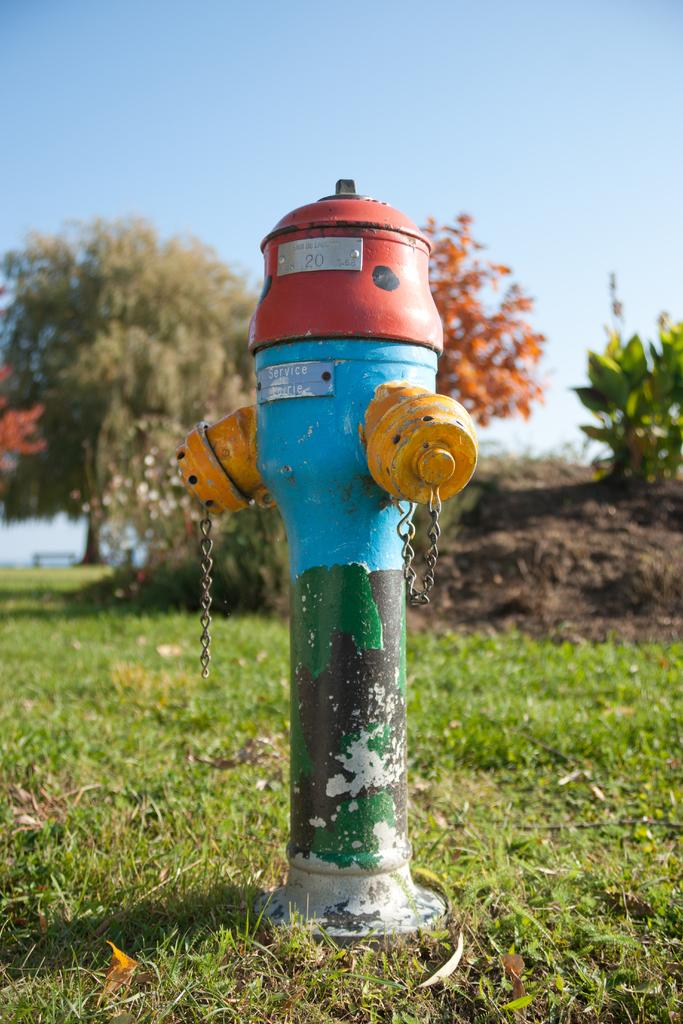<image>
Share a concise interpretation of the image provided. A strange and colorful fire hydrant with a number 20 on the silver plate. 